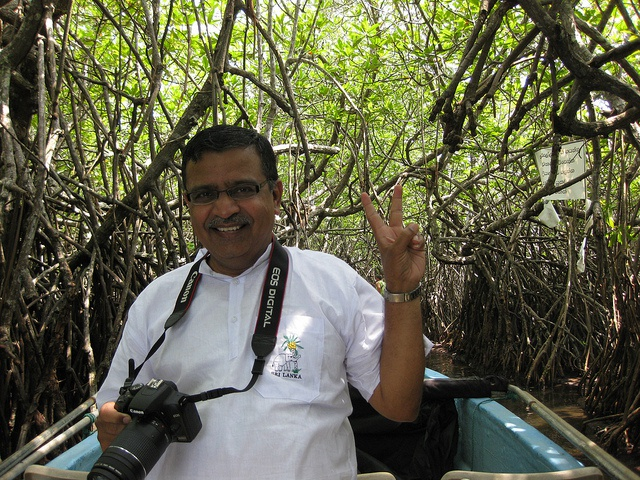Describe the objects in this image and their specific colors. I can see people in black, darkgray, and maroon tones, boat in black, teal, and gray tones, and backpack in black and darkgreen tones in this image. 